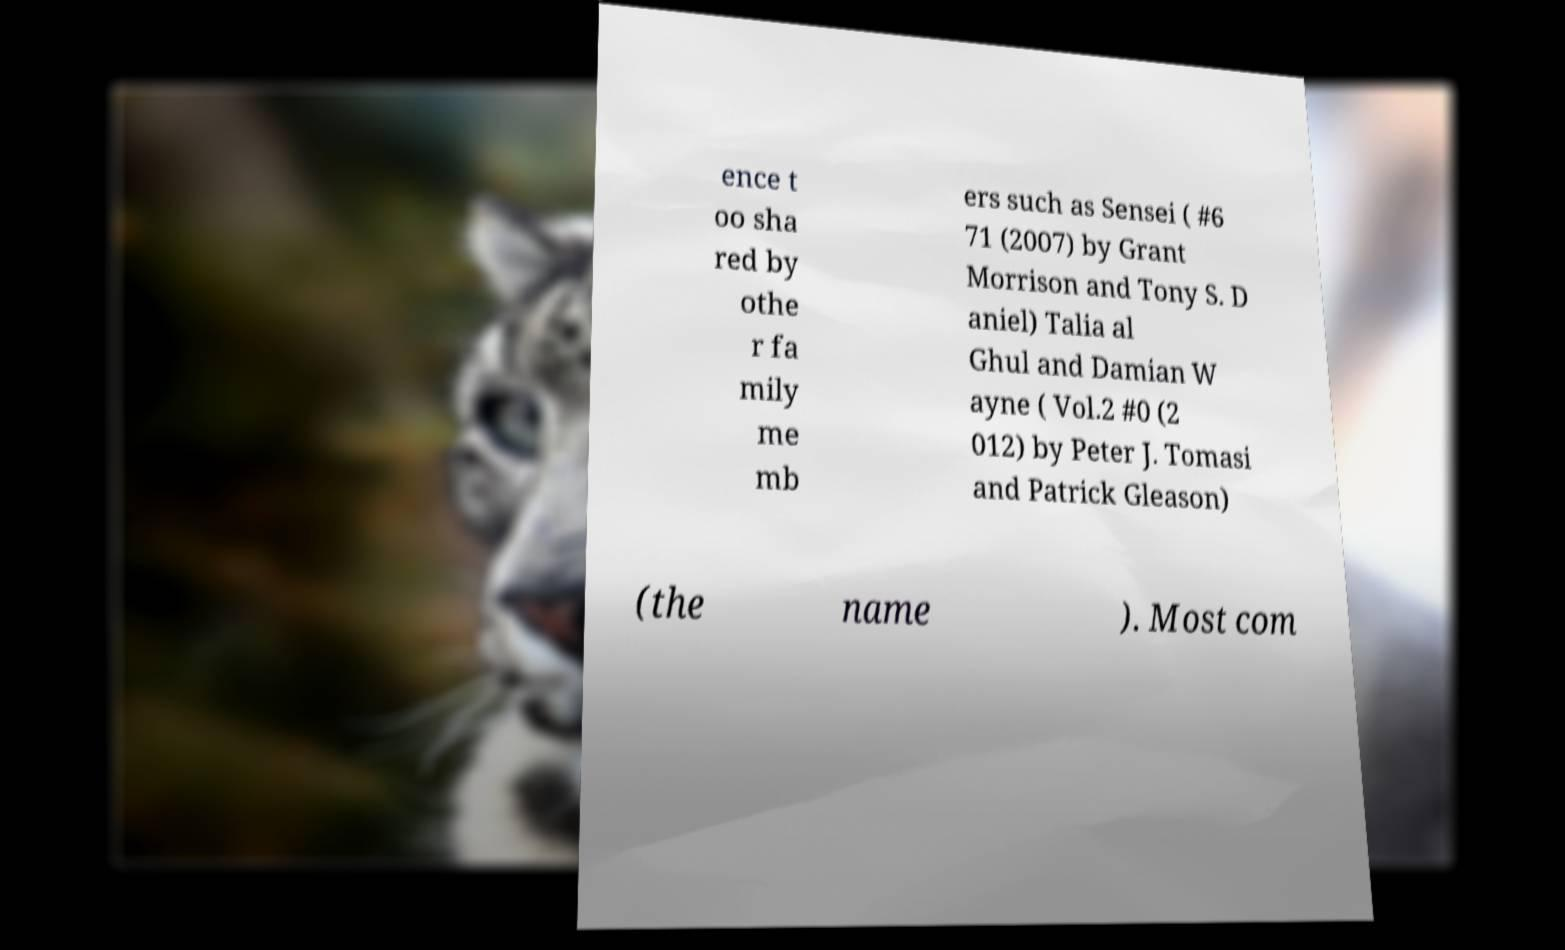What messages or text are displayed in this image? I need them in a readable, typed format. ence t oo sha red by othe r fa mily me mb ers such as Sensei ( #6 71 (2007) by Grant Morrison and Tony S. D aniel) Talia al Ghul and Damian W ayne ( Vol.2 #0 (2 012) by Peter J. Tomasi and Patrick Gleason) (the name ). Most com 